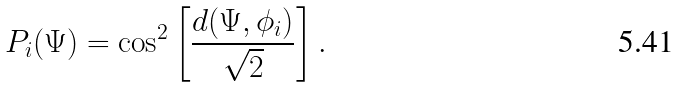Convert formula to latex. <formula><loc_0><loc_0><loc_500><loc_500>P _ { i } ( \Psi ) = \cos ^ { 2 } \left [ \frac { d ( \Psi , \phi _ { i } ) } { \sqrt { 2 } } \right ] .</formula> 